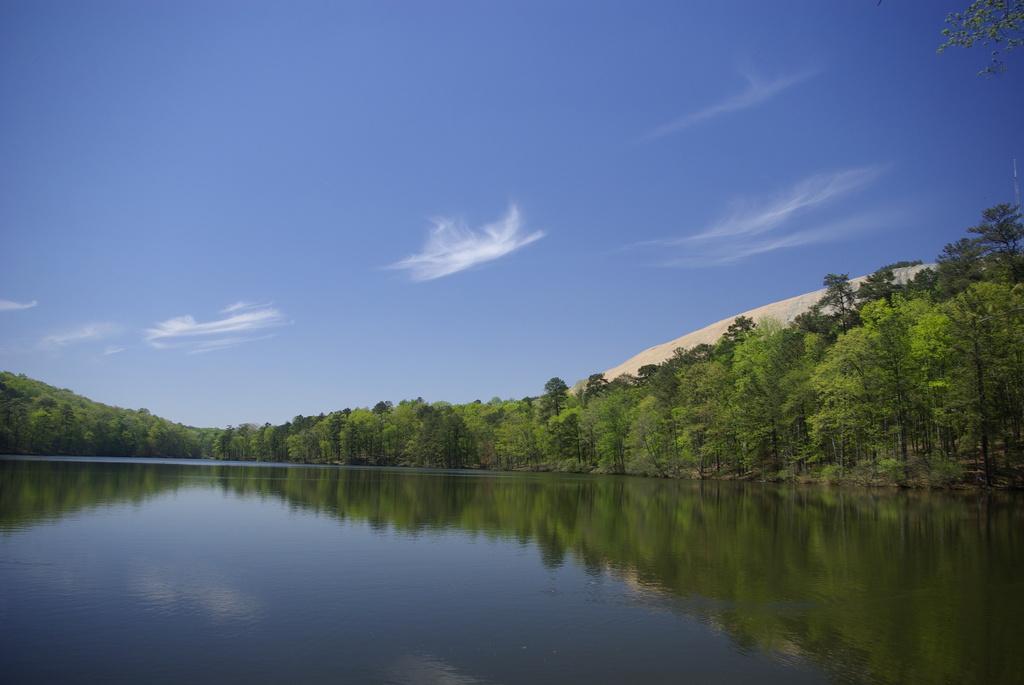Please provide a concise description of this image. In this image I can see few green trees and the water. The sky is in blue and white color. 